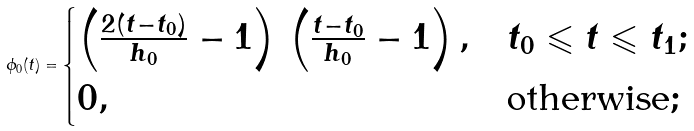Convert formula to latex. <formula><loc_0><loc_0><loc_500><loc_500>\phi _ { 0 } ( t ) = \begin{cases} \left ( \frac { 2 ( t - t _ { 0 } ) } { h _ { 0 } } - 1 \right ) \, \left ( \frac { t - t _ { 0 } } { h _ { 0 } } - 1 \right ) , & t _ { 0 } \leqslant t \leqslant t _ { 1 } ; \\ 0 , & \text {otherwise} ; \end{cases}</formula> 